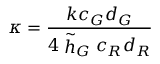<formula> <loc_0><loc_0><loc_500><loc_500>\kappa = \frac { k c _ { G } d _ { G } } { 4 \stackrel { \sim } { h } _ { G } c _ { R } d _ { R } }</formula> 